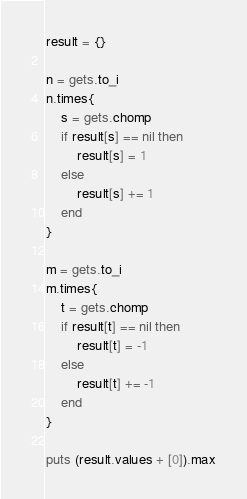Convert code to text. <code><loc_0><loc_0><loc_500><loc_500><_Ruby_>result = {}

n = gets.to_i
n.times{
	s = gets.chomp
	if result[s] == nil then
		result[s] = 1
	else
		result[s] += 1
	end
}

m = gets.to_i
m.times{
	t = gets.chomp
	if result[t] == nil then
		result[t] = -1
	else
		result[t] += -1
	end
}

puts (result.values + [0]).max
</code> 